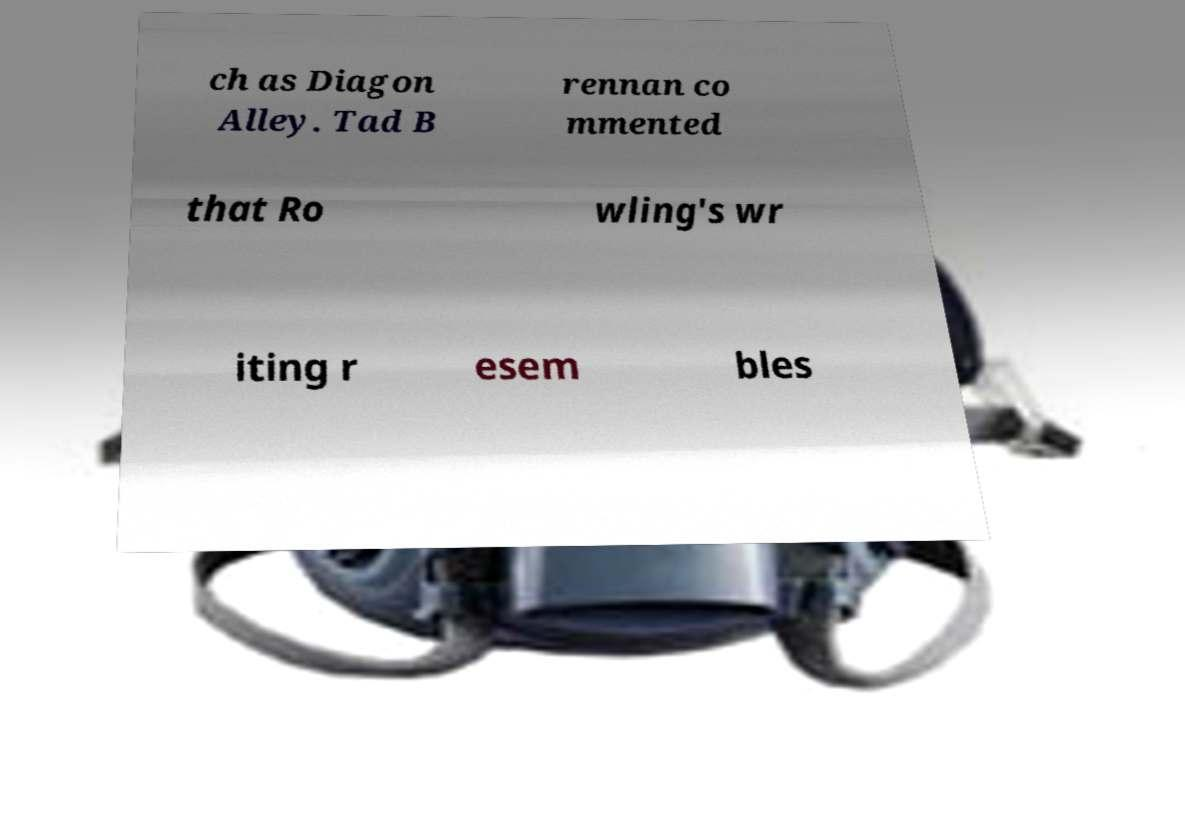For documentation purposes, I need the text within this image transcribed. Could you provide that? ch as Diagon Alley. Tad B rennan co mmented that Ro wling's wr iting r esem bles 